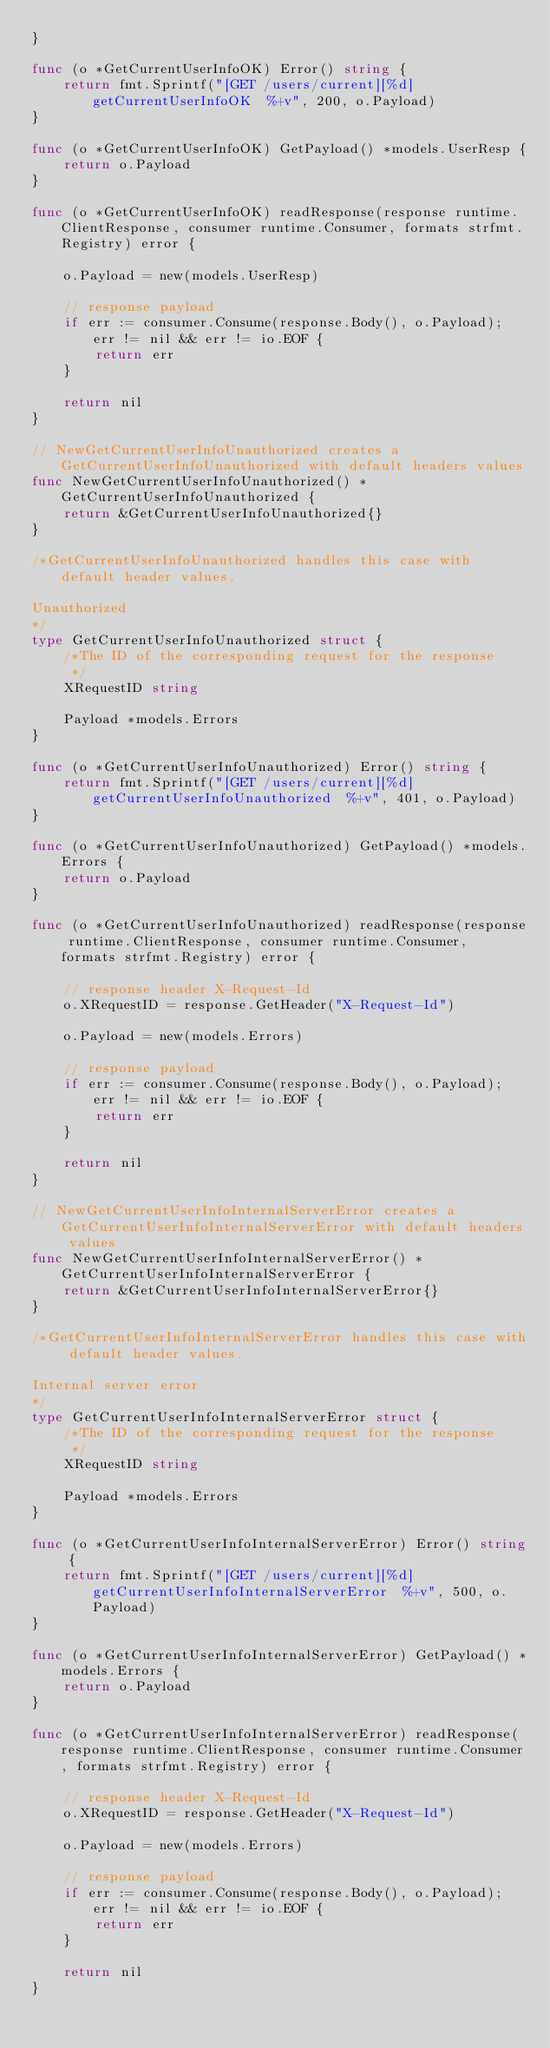<code> <loc_0><loc_0><loc_500><loc_500><_Go_>}

func (o *GetCurrentUserInfoOK) Error() string {
	return fmt.Sprintf("[GET /users/current][%d] getCurrentUserInfoOK  %+v", 200, o.Payload)
}

func (o *GetCurrentUserInfoOK) GetPayload() *models.UserResp {
	return o.Payload
}

func (o *GetCurrentUserInfoOK) readResponse(response runtime.ClientResponse, consumer runtime.Consumer, formats strfmt.Registry) error {

	o.Payload = new(models.UserResp)

	// response payload
	if err := consumer.Consume(response.Body(), o.Payload); err != nil && err != io.EOF {
		return err
	}

	return nil
}

// NewGetCurrentUserInfoUnauthorized creates a GetCurrentUserInfoUnauthorized with default headers values
func NewGetCurrentUserInfoUnauthorized() *GetCurrentUserInfoUnauthorized {
	return &GetCurrentUserInfoUnauthorized{}
}

/*GetCurrentUserInfoUnauthorized handles this case with default header values.

Unauthorized
*/
type GetCurrentUserInfoUnauthorized struct {
	/*The ID of the corresponding request for the response
	 */
	XRequestID string

	Payload *models.Errors
}

func (o *GetCurrentUserInfoUnauthorized) Error() string {
	return fmt.Sprintf("[GET /users/current][%d] getCurrentUserInfoUnauthorized  %+v", 401, o.Payload)
}

func (o *GetCurrentUserInfoUnauthorized) GetPayload() *models.Errors {
	return o.Payload
}

func (o *GetCurrentUserInfoUnauthorized) readResponse(response runtime.ClientResponse, consumer runtime.Consumer, formats strfmt.Registry) error {

	// response header X-Request-Id
	o.XRequestID = response.GetHeader("X-Request-Id")

	o.Payload = new(models.Errors)

	// response payload
	if err := consumer.Consume(response.Body(), o.Payload); err != nil && err != io.EOF {
		return err
	}

	return nil
}

// NewGetCurrentUserInfoInternalServerError creates a GetCurrentUserInfoInternalServerError with default headers values
func NewGetCurrentUserInfoInternalServerError() *GetCurrentUserInfoInternalServerError {
	return &GetCurrentUserInfoInternalServerError{}
}

/*GetCurrentUserInfoInternalServerError handles this case with default header values.

Internal server error
*/
type GetCurrentUserInfoInternalServerError struct {
	/*The ID of the corresponding request for the response
	 */
	XRequestID string

	Payload *models.Errors
}

func (o *GetCurrentUserInfoInternalServerError) Error() string {
	return fmt.Sprintf("[GET /users/current][%d] getCurrentUserInfoInternalServerError  %+v", 500, o.Payload)
}

func (o *GetCurrentUserInfoInternalServerError) GetPayload() *models.Errors {
	return o.Payload
}

func (o *GetCurrentUserInfoInternalServerError) readResponse(response runtime.ClientResponse, consumer runtime.Consumer, formats strfmt.Registry) error {

	// response header X-Request-Id
	o.XRequestID = response.GetHeader("X-Request-Id")

	o.Payload = new(models.Errors)

	// response payload
	if err := consumer.Consume(response.Body(), o.Payload); err != nil && err != io.EOF {
		return err
	}

	return nil
}
</code> 